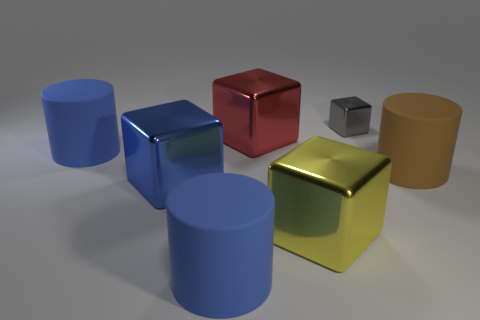Subtract all large blocks. How many blocks are left? 1 Add 2 big brown matte cylinders. How many objects exist? 9 Subtract all blue cylinders. How many cylinders are left? 1 Subtract all yellow balls. How many blue cylinders are left? 2 Subtract all yellow metal cylinders. Subtract all gray metal things. How many objects are left? 6 Add 5 big metallic things. How many big metallic things are left? 8 Add 3 cubes. How many cubes exist? 7 Subtract 0 gray cylinders. How many objects are left? 7 Subtract all blocks. How many objects are left? 3 Subtract all yellow cubes. Subtract all yellow cylinders. How many cubes are left? 3 